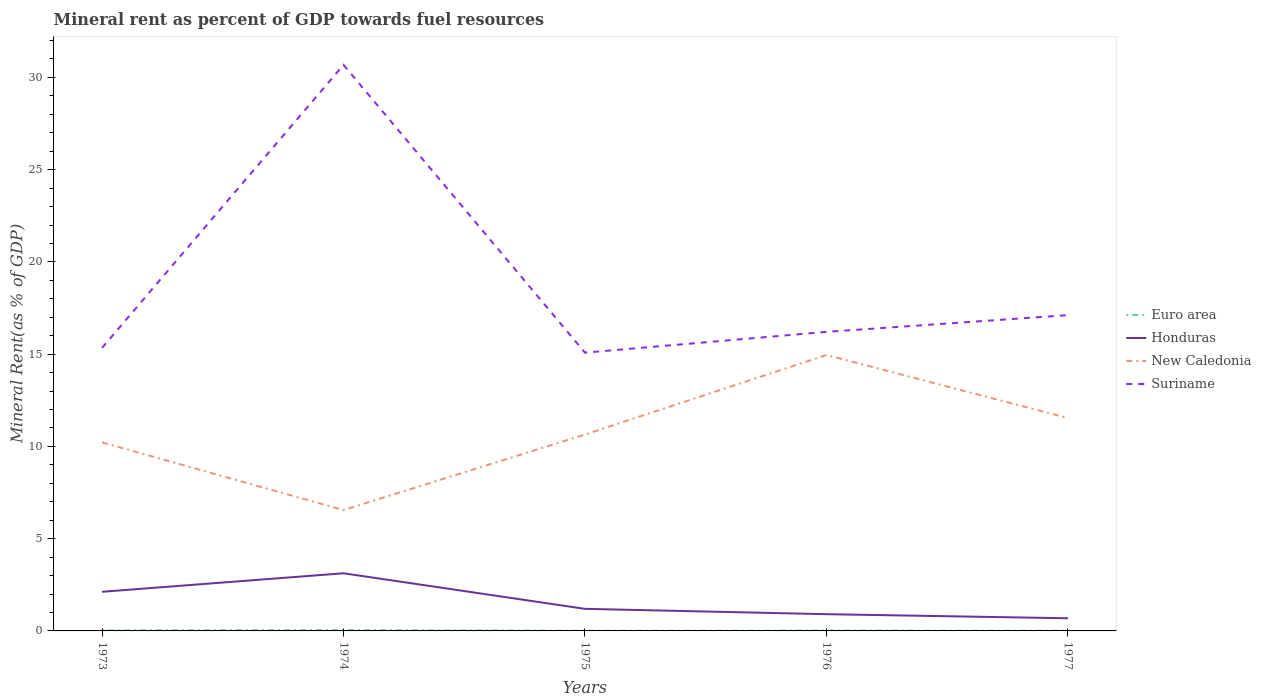Is the number of lines equal to the number of legend labels?
Ensure brevity in your answer.  Yes. Across all years, what is the maximum mineral rent in Suriname?
Ensure brevity in your answer.  15.08. In which year was the mineral rent in Honduras maximum?
Your answer should be very brief. 1977. What is the total mineral rent in Suriname in the graph?
Offer a very short reply. 15.6. What is the difference between the highest and the second highest mineral rent in Euro area?
Offer a terse response. 0.03. What is the difference between the highest and the lowest mineral rent in New Caledonia?
Make the answer very short. 2. What is the difference between two consecutive major ticks on the Y-axis?
Ensure brevity in your answer.  5. Are the values on the major ticks of Y-axis written in scientific E-notation?
Offer a very short reply. No. Where does the legend appear in the graph?
Offer a terse response. Center right. What is the title of the graph?
Provide a succinct answer. Mineral rent as percent of GDP towards fuel resources. What is the label or title of the Y-axis?
Your answer should be very brief. Mineral Rent(as % of GDP). What is the Mineral Rent(as % of GDP) of Euro area in 1973?
Your answer should be compact. 0.03. What is the Mineral Rent(as % of GDP) of Honduras in 1973?
Provide a succinct answer. 2.12. What is the Mineral Rent(as % of GDP) of New Caledonia in 1973?
Your answer should be very brief. 10.22. What is the Mineral Rent(as % of GDP) of Suriname in 1973?
Offer a terse response. 15.34. What is the Mineral Rent(as % of GDP) of Euro area in 1974?
Keep it short and to the point. 0.05. What is the Mineral Rent(as % of GDP) in Honduras in 1974?
Your response must be concise. 3.12. What is the Mineral Rent(as % of GDP) in New Caledonia in 1974?
Your answer should be very brief. 6.55. What is the Mineral Rent(as % of GDP) of Suriname in 1974?
Provide a short and direct response. 30.68. What is the Mineral Rent(as % of GDP) of Euro area in 1975?
Provide a short and direct response. 0.01. What is the Mineral Rent(as % of GDP) of Honduras in 1975?
Give a very brief answer. 1.2. What is the Mineral Rent(as % of GDP) in New Caledonia in 1975?
Offer a very short reply. 10.64. What is the Mineral Rent(as % of GDP) of Suriname in 1975?
Your answer should be compact. 15.08. What is the Mineral Rent(as % of GDP) of Euro area in 1976?
Your response must be concise. 0.02. What is the Mineral Rent(as % of GDP) of Honduras in 1976?
Give a very brief answer. 0.91. What is the Mineral Rent(as % of GDP) in New Caledonia in 1976?
Your answer should be compact. 14.96. What is the Mineral Rent(as % of GDP) of Suriname in 1976?
Ensure brevity in your answer.  16.21. What is the Mineral Rent(as % of GDP) in Euro area in 1977?
Make the answer very short. 0.02. What is the Mineral Rent(as % of GDP) of Honduras in 1977?
Offer a very short reply. 0.69. What is the Mineral Rent(as % of GDP) in New Caledonia in 1977?
Your answer should be compact. 11.54. What is the Mineral Rent(as % of GDP) in Suriname in 1977?
Provide a short and direct response. 17.12. Across all years, what is the maximum Mineral Rent(as % of GDP) in Euro area?
Make the answer very short. 0.05. Across all years, what is the maximum Mineral Rent(as % of GDP) of Honduras?
Provide a short and direct response. 3.12. Across all years, what is the maximum Mineral Rent(as % of GDP) of New Caledonia?
Your answer should be very brief. 14.96. Across all years, what is the maximum Mineral Rent(as % of GDP) of Suriname?
Your answer should be compact. 30.68. Across all years, what is the minimum Mineral Rent(as % of GDP) in Euro area?
Offer a very short reply. 0.01. Across all years, what is the minimum Mineral Rent(as % of GDP) in Honduras?
Give a very brief answer. 0.69. Across all years, what is the minimum Mineral Rent(as % of GDP) in New Caledonia?
Provide a succinct answer. 6.55. Across all years, what is the minimum Mineral Rent(as % of GDP) in Suriname?
Offer a very short reply. 15.08. What is the total Mineral Rent(as % of GDP) in Euro area in the graph?
Make the answer very short. 0.13. What is the total Mineral Rent(as % of GDP) of Honduras in the graph?
Offer a terse response. 8.04. What is the total Mineral Rent(as % of GDP) in New Caledonia in the graph?
Make the answer very short. 53.91. What is the total Mineral Rent(as % of GDP) of Suriname in the graph?
Your answer should be compact. 94.43. What is the difference between the Mineral Rent(as % of GDP) of Euro area in 1973 and that in 1974?
Provide a short and direct response. -0.01. What is the difference between the Mineral Rent(as % of GDP) of Honduras in 1973 and that in 1974?
Provide a succinct answer. -1. What is the difference between the Mineral Rent(as % of GDP) of New Caledonia in 1973 and that in 1974?
Ensure brevity in your answer.  3.67. What is the difference between the Mineral Rent(as % of GDP) in Suriname in 1973 and that in 1974?
Keep it short and to the point. -15.34. What is the difference between the Mineral Rent(as % of GDP) of Euro area in 1973 and that in 1975?
Offer a terse response. 0.02. What is the difference between the Mineral Rent(as % of GDP) of Honduras in 1973 and that in 1975?
Offer a very short reply. 0.92. What is the difference between the Mineral Rent(as % of GDP) of New Caledonia in 1973 and that in 1975?
Give a very brief answer. -0.42. What is the difference between the Mineral Rent(as % of GDP) in Suriname in 1973 and that in 1975?
Your answer should be very brief. 0.26. What is the difference between the Mineral Rent(as % of GDP) of Euro area in 1973 and that in 1976?
Make the answer very short. 0.01. What is the difference between the Mineral Rent(as % of GDP) in Honduras in 1973 and that in 1976?
Offer a very short reply. 1.21. What is the difference between the Mineral Rent(as % of GDP) of New Caledonia in 1973 and that in 1976?
Offer a very short reply. -4.74. What is the difference between the Mineral Rent(as % of GDP) of Suriname in 1973 and that in 1976?
Give a very brief answer. -0.87. What is the difference between the Mineral Rent(as % of GDP) in Euro area in 1973 and that in 1977?
Provide a short and direct response. 0.02. What is the difference between the Mineral Rent(as % of GDP) of Honduras in 1973 and that in 1977?
Offer a very short reply. 1.44. What is the difference between the Mineral Rent(as % of GDP) in New Caledonia in 1973 and that in 1977?
Provide a short and direct response. -1.32. What is the difference between the Mineral Rent(as % of GDP) in Suriname in 1973 and that in 1977?
Keep it short and to the point. -1.78. What is the difference between the Mineral Rent(as % of GDP) of Euro area in 1974 and that in 1975?
Your answer should be compact. 0.03. What is the difference between the Mineral Rent(as % of GDP) in Honduras in 1974 and that in 1975?
Offer a terse response. 1.93. What is the difference between the Mineral Rent(as % of GDP) of New Caledonia in 1974 and that in 1975?
Provide a short and direct response. -4.09. What is the difference between the Mineral Rent(as % of GDP) in Suriname in 1974 and that in 1975?
Offer a very short reply. 15.6. What is the difference between the Mineral Rent(as % of GDP) in Euro area in 1974 and that in 1976?
Your answer should be very brief. 0.03. What is the difference between the Mineral Rent(as % of GDP) in Honduras in 1974 and that in 1976?
Give a very brief answer. 2.22. What is the difference between the Mineral Rent(as % of GDP) in New Caledonia in 1974 and that in 1976?
Your answer should be very brief. -8.41. What is the difference between the Mineral Rent(as % of GDP) in Suriname in 1974 and that in 1976?
Offer a very short reply. 14.47. What is the difference between the Mineral Rent(as % of GDP) in Euro area in 1974 and that in 1977?
Keep it short and to the point. 0.03. What is the difference between the Mineral Rent(as % of GDP) of Honduras in 1974 and that in 1977?
Provide a short and direct response. 2.44. What is the difference between the Mineral Rent(as % of GDP) of New Caledonia in 1974 and that in 1977?
Give a very brief answer. -4.99. What is the difference between the Mineral Rent(as % of GDP) of Suriname in 1974 and that in 1977?
Give a very brief answer. 13.56. What is the difference between the Mineral Rent(as % of GDP) of Euro area in 1975 and that in 1976?
Keep it short and to the point. -0.01. What is the difference between the Mineral Rent(as % of GDP) of Honduras in 1975 and that in 1976?
Offer a very short reply. 0.29. What is the difference between the Mineral Rent(as % of GDP) in New Caledonia in 1975 and that in 1976?
Offer a very short reply. -4.31. What is the difference between the Mineral Rent(as % of GDP) of Suriname in 1975 and that in 1976?
Your response must be concise. -1.13. What is the difference between the Mineral Rent(as % of GDP) of Euro area in 1975 and that in 1977?
Your answer should be very brief. -0. What is the difference between the Mineral Rent(as % of GDP) in Honduras in 1975 and that in 1977?
Offer a terse response. 0.51. What is the difference between the Mineral Rent(as % of GDP) in New Caledonia in 1975 and that in 1977?
Ensure brevity in your answer.  -0.89. What is the difference between the Mineral Rent(as % of GDP) in Suriname in 1975 and that in 1977?
Ensure brevity in your answer.  -2.03. What is the difference between the Mineral Rent(as % of GDP) in Euro area in 1976 and that in 1977?
Ensure brevity in your answer.  0. What is the difference between the Mineral Rent(as % of GDP) in Honduras in 1976 and that in 1977?
Your answer should be very brief. 0.22. What is the difference between the Mineral Rent(as % of GDP) in New Caledonia in 1976 and that in 1977?
Your response must be concise. 3.42. What is the difference between the Mineral Rent(as % of GDP) in Suriname in 1976 and that in 1977?
Your response must be concise. -0.91. What is the difference between the Mineral Rent(as % of GDP) in Euro area in 1973 and the Mineral Rent(as % of GDP) in Honduras in 1974?
Give a very brief answer. -3.09. What is the difference between the Mineral Rent(as % of GDP) in Euro area in 1973 and the Mineral Rent(as % of GDP) in New Caledonia in 1974?
Offer a terse response. -6.52. What is the difference between the Mineral Rent(as % of GDP) of Euro area in 1973 and the Mineral Rent(as % of GDP) of Suriname in 1974?
Keep it short and to the point. -30.65. What is the difference between the Mineral Rent(as % of GDP) in Honduras in 1973 and the Mineral Rent(as % of GDP) in New Caledonia in 1974?
Offer a very short reply. -4.43. What is the difference between the Mineral Rent(as % of GDP) in Honduras in 1973 and the Mineral Rent(as % of GDP) in Suriname in 1974?
Provide a short and direct response. -28.56. What is the difference between the Mineral Rent(as % of GDP) in New Caledonia in 1973 and the Mineral Rent(as % of GDP) in Suriname in 1974?
Give a very brief answer. -20.46. What is the difference between the Mineral Rent(as % of GDP) of Euro area in 1973 and the Mineral Rent(as % of GDP) of Honduras in 1975?
Offer a terse response. -1.16. What is the difference between the Mineral Rent(as % of GDP) of Euro area in 1973 and the Mineral Rent(as % of GDP) of New Caledonia in 1975?
Your answer should be compact. -10.61. What is the difference between the Mineral Rent(as % of GDP) in Euro area in 1973 and the Mineral Rent(as % of GDP) in Suriname in 1975?
Provide a short and direct response. -15.05. What is the difference between the Mineral Rent(as % of GDP) of Honduras in 1973 and the Mineral Rent(as % of GDP) of New Caledonia in 1975?
Offer a very short reply. -8.52. What is the difference between the Mineral Rent(as % of GDP) of Honduras in 1973 and the Mineral Rent(as % of GDP) of Suriname in 1975?
Keep it short and to the point. -12.96. What is the difference between the Mineral Rent(as % of GDP) in New Caledonia in 1973 and the Mineral Rent(as % of GDP) in Suriname in 1975?
Your answer should be compact. -4.86. What is the difference between the Mineral Rent(as % of GDP) of Euro area in 1973 and the Mineral Rent(as % of GDP) of Honduras in 1976?
Your answer should be very brief. -0.88. What is the difference between the Mineral Rent(as % of GDP) of Euro area in 1973 and the Mineral Rent(as % of GDP) of New Caledonia in 1976?
Provide a short and direct response. -14.92. What is the difference between the Mineral Rent(as % of GDP) in Euro area in 1973 and the Mineral Rent(as % of GDP) in Suriname in 1976?
Provide a short and direct response. -16.18. What is the difference between the Mineral Rent(as % of GDP) in Honduras in 1973 and the Mineral Rent(as % of GDP) in New Caledonia in 1976?
Provide a short and direct response. -12.84. What is the difference between the Mineral Rent(as % of GDP) in Honduras in 1973 and the Mineral Rent(as % of GDP) in Suriname in 1976?
Give a very brief answer. -14.09. What is the difference between the Mineral Rent(as % of GDP) of New Caledonia in 1973 and the Mineral Rent(as % of GDP) of Suriname in 1976?
Keep it short and to the point. -5.99. What is the difference between the Mineral Rent(as % of GDP) of Euro area in 1973 and the Mineral Rent(as % of GDP) of Honduras in 1977?
Give a very brief answer. -0.65. What is the difference between the Mineral Rent(as % of GDP) of Euro area in 1973 and the Mineral Rent(as % of GDP) of New Caledonia in 1977?
Ensure brevity in your answer.  -11.51. What is the difference between the Mineral Rent(as % of GDP) in Euro area in 1973 and the Mineral Rent(as % of GDP) in Suriname in 1977?
Your response must be concise. -17.08. What is the difference between the Mineral Rent(as % of GDP) of Honduras in 1973 and the Mineral Rent(as % of GDP) of New Caledonia in 1977?
Your answer should be very brief. -9.42. What is the difference between the Mineral Rent(as % of GDP) in Honduras in 1973 and the Mineral Rent(as % of GDP) in Suriname in 1977?
Provide a succinct answer. -15. What is the difference between the Mineral Rent(as % of GDP) of New Caledonia in 1973 and the Mineral Rent(as % of GDP) of Suriname in 1977?
Ensure brevity in your answer.  -6.9. What is the difference between the Mineral Rent(as % of GDP) in Euro area in 1974 and the Mineral Rent(as % of GDP) in Honduras in 1975?
Your answer should be compact. -1.15. What is the difference between the Mineral Rent(as % of GDP) of Euro area in 1974 and the Mineral Rent(as % of GDP) of New Caledonia in 1975?
Give a very brief answer. -10.6. What is the difference between the Mineral Rent(as % of GDP) in Euro area in 1974 and the Mineral Rent(as % of GDP) in Suriname in 1975?
Your answer should be compact. -15.04. What is the difference between the Mineral Rent(as % of GDP) in Honduras in 1974 and the Mineral Rent(as % of GDP) in New Caledonia in 1975?
Your answer should be compact. -7.52. What is the difference between the Mineral Rent(as % of GDP) of Honduras in 1974 and the Mineral Rent(as % of GDP) of Suriname in 1975?
Keep it short and to the point. -11.96. What is the difference between the Mineral Rent(as % of GDP) of New Caledonia in 1974 and the Mineral Rent(as % of GDP) of Suriname in 1975?
Provide a short and direct response. -8.53. What is the difference between the Mineral Rent(as % of GDP) in Euro area in 1974 and the Mineral Rent(as % of GDP) in Honduras in 1976?
Offer a terse response. -0.86. What is the difference between the Mineral Rent(as % of GDP) in Euro area in 1974 and the Mineral Rent(as % of GDP) in New Caledonia in 1976?
Give a very brief answer. -14.91. What is the difference between the Mineral Rent(as % of GDP) of Euro area in 1974 and the Mineral Rent(as % of GDP) of Suriname in 1976?
Keep it short and to the point. -16.16. What is the difference between the Mineral Rent(as % of GDP) of Honduras in 1974 and the Mineral Rent(as % of GDP) of New Caledonia in 1976?
Offer a terse response. -11.83. What is the difference between the Mineral Rent(as % of GDP) in Honduras in 1974 and the Mineral Rent(as % of GDP) in Suriname in 1976?
Provide a short and direct response. -13.08. What is the difference between the Mineral Rent(as % of GDP) in New Caledonia in 1974 and the Mineral Rent(as % of GDP) in Suriname in 1976?
Your answer should be compact. -9.66. What is the difference between the Mineral Rent(as % of GDP) in Euro area in 1974 and the Mineral Rent(as % of GDP) in Honduras in 1977?
Your response must be concise. -0.64. What is the difference between the Mineral Rent(as % of GDP) in Euro area in 1974 and the Mineral Rent(as % of GDP) in New Caledonia in 1977?
Offer a terse response. -11.49. What is the difference between the Mineral Rent(as % of GDP) of Euro area in 1974 and the Mineral Rent(as % of GDP) of Suriname in 1977?
Your answer should be compact. -17.07. What is the difference between the Mineral Rent(as % of GDP) in Honduras in 1974 and the Mineral Rent(as % of GDP) in New Caledonia in 1977?
Offer a very short reply. -8.41. What is the difference between the Mineral Rent(as % of GDP) of Honduras in 1974 and the Mineral Rent(as % of GDP) of Suriname in 1977?
Ensure brevity in your answer.  -13.99. What is the difference between the Mineral Rent(as % of GDP) in New Caledonia in 1974 and the Mineral Rent(as % of GDP) in Suriname in 1977?
Offer a very short reply. -10.57. What is the difference between the Mineral Rent(as % of GDP) in Euro area in 1975 and the Mineral Rent(as % of GDP) in Honduras in 1976?
Make the answer very short. -0.89. What is the difference between the Mineral Rent(as % of GDP) in Euro area in 1975 and the Mineral Rent(as % of GDP) in New Caledonia in 1976?
Provide a short and direct response. -14.94. What is the difference between the Mineral Rent(as % of GDP) of Euro area in 1975 and the Mineral Rent(as % of GDP) of Suriname in 1976?
Offer a very short reply. -16.2. What is the difference between the Mineral Rent(as % of GDP) of Honduras in 1975 and the Mineral Rent(as % of GDP) of New Caledonia in 1976?
Provide a succinct answer. -13.76. What is the difference between the Mineral Rent(as % of GDP) of Honduras in 1975 and the Mineral Rent(as % of GDP) of Suriname in 1976?
Your response must be concise. -15.01. What is the difference between the Mineral Rent(as % of GDP) of New Caledonia in 1975 and the Mineral Rent(as % of GDP) of Suriname in 1976?
Your answer should be compact. -5.57. What is the difference between the Mineral Rent(as % of GDP) of Euro area in 1975 and the Mineral Rent(as % of GDP) of Honduras in 1977?
Your response must be concise. -0.67. What is the difference between the Mineral Rent(as % of GDP) of Euro area in 1975 and the Mineral Rent(as % of GDP) of New Caledonia in 1977?
Provide a short and direct response. -11.52. What is the difference between the Mineral Rent(as % of GDP) in Euro area in 1975 and the Mineral Rent(as % of GDP) in Suriname in 1977?
Give a very brief answer. -17.1. What is the difference between the Mineral Rent(as % of GDP) in Honduras in 1975 and the Mineral Rent(as % of GDP) in New Caledonia in 1977?
Ensure brevity in your answer.  -10.34. What is the difference between the Mineral Rent(as % of GDP) of Honduras in 1975 and the Mineral Rent(as % of GDP) of Suriname in 1977?
Offer a very short reply. -15.92. What is the difference between the Mineral Rent(as % of GDP) of New Caledonia in 1975 and the Mineral Rent(as % of GDP) of Suriname in 1977?
Your response must be concise. -6.47. What is the difference between the Mineral Rent(as % of GDP) of Euro area in 1976 and the Mineral Rent(as % of GDP) of Honduras in 1977?
Ensure brevity in your answer.  -0.67. What is the difference between the Mineral Rent(as % of GDP) of Euro area in 1976 and the Mineral Rent(as % of GDP) of New Caledonia in 1977?
Provide a short and direct response. -11.52. What is the difference between the Mineral Rent(as % of GDP) of Euro area in 1976 and the Mineral Rent(as % of GDP) of Suriname in 1977?
Provide a succinct answer. -17.1. What is the difference between the Mineral Rent(as % of GDP) in Honduras in 1976 and the Mineral Rent(as % of GDP) in New Caledonia in 1977?
Your response must be concise. -10.63. What is the difference between the Mineral Rent(as % of GDP) of Honduras in 1976 and the Mineral Rent(as % of GDP) of Suriname in 1977?
Your response must be concise. -16.21. What is the difference between the Mineral Rent(as % of GDP) of New Caledonia in 1976 and the Mineral Rent(as % of GDP) of Suriname in 1977?
Your response must be concise. -2.16. What is the average Mineral Rent(as % of GDP) of Euro area per year?
Provide a succinct answer. 0.03. What is the average Mineral Rent(as % of GDP) in Honduras per year?
Your answer should be compact. 1.61. What is the average Mineral Rent(as % of GDP) of New Caledonia per year?
Provide a short and direct response. 10.78. What is the average Mineral Rent(as % of GDP) in Suriname per year?
Offer a terse response. 18.89. In the year 1973, what is the difference between the Mineral Rent(as % of GDP) of Euro area and Mineral Rent(as % of GDP) of Honduras?
Provide a succinct answer. -2.09. In the year 1973, what is the difference between the Mineral Rent(as % of GDP) of Euro area and Mineral Rent(as % of GDP) of New Caledonia?
Your answer should be compact. -10.19. In the year 1973, what is the difference between the Mineral Rent(as % of GDP) of Euro area and Mineral Rent(as % of GDP) of Suriname?
Give a very brief answer. -15.31. In the year 1973, what is the difference between the Mineral Rent(as % of GDP) in Honduras and Mineral Rent(as % of GDP) in New Caledonia?
Ensure brevity in your answer.  -8.1. In the year 1973, what is the difference between the Mineral Rent(as % of GDP) in Honduras and Mineral Rent(as % of GDP) in Suriname?
Make the answer very short. -13.22. In the year 1973, what is the difference between the Mineral Rent(as % of GDP) of New Caledonia and Mineral Rent(as % of GDP) of Suriname?
Your response must be concise. -5.12. In the year 1974, what is the difference between the Mineral Rent(as % of GDP) of Euro area and Mineral Rent(as % of GDP) of Honduras?
Offer a very short reply. -3.08. In the year 1974, what is the difference between the Mineral Rent(as % of GDP) in Euro area and Mineral Rent(as % of GDP) in New Caledonia?
Your answer should be very brief. -6.51. In the year 1974, what is the difference between the Mineral Rent(as % of GDP) in Euro area and Mineral Rent(as % of GDP) in Suriname?
Provide a succinct answer. -30.64. In the year 1974, what is the difference between the Mineral Rent(as % of GDP) of Honduras and Mineral Rent(as % of GDP) of New Caledonia?
Your answer should be compact. -3.43. In the year 1974, what is the difference between the Mineral Rent(as % of GDP) in Honduras and Mineral Rent(as % of GDP) in Suriname?
Your response must be concise. -27.56. In the year 1974, what is the difference between the Mineral Rent(as % of GDP) of New Caledonia and Mineral Rent(as % of GDP) of Suriname?
Your answer should be compact. -24.13. In the year 1975, what is the difference between the Mineral Rent(as % of GDP) of Euro area and Mineral Rent(as % of GDP) of Honduras?
Provide a short and direct response. -1.18. In the year 1975, what is the difference between the Mineral Rent(as % of GDP) in Euro area and Mineral Rent(as % of GDP) in New Caledonia?
Make the answer very short. -10.63. In the year 1975, what is the difference between the Mineral Rent(as % of GDP) in Euro area and Mineral Rent(as % of GDP) in Suriname?
Offer a terse response. -15.07. In the year 1975, what is the difference between the Mineral Rent(as % of GDP) of Honduras and Mineral Rent(as % of GDP) of New Caledonia?
Offer a terse response. -9.45. In the year 1975, what is the difference between the Mineral Rent(as % of GDP) in Honduras and Mineral Rent(as % of GDP) in Suriname?
Keep it short and to the point. -13.89. In the year 1975, what is the difference between the Mineral Rent(as % of GDP) in New Caledonia and Mineral Rent(as % of GDP) in Suriname?
Your answer should be very brief. -4.44. In the year 1976, what is the difference between the Mineral Rent(as % of GDP) of Euro area and Mineral Rent(as % of GDP) of Honduras?
Offer a terse response. -0.89. In the year 1976, what is the difference between the Mineral Rent(as % of GDP) in Euro area and Mineral Rent(as % of GDP) in New Caledonia?
Your response must be concise. -14.94. In the year 1976, what is the difference between the Mineral Rent(as % of GDP) of Euro area and Mineral Rent(as % of GDP) of Suriname?
Give a very brief answer. -16.19. In the year 1976, what is the difference between the Mineral Rent(as % of GDP) in Honduras and Mineral Rent(as % of GDP) in New Caledonia?
Offer a terse response. -14.05. In the year 1976, what is the difference between the Mineral Rent(as % of GDP) of Honduras and Mineral Rent(as % of GDP) of Suriname?
Provide a short and direct response. -15.3. In the year 1976, what is the difference between the Mineral Rent(as % of GDP) in New Caledonia and Mineral Rent(as % of GDP) in Suriname?
Your answer should be very brief. -1.25. In the year 1977, what is the difference between the Mineral Rent(as % of GDP) in Euro area and Mineral Rent(as % of GDP) in Honduras?
Ensure brevity in your answer.  -0.67. In the year 1977, what is the difference between the Mineral Rent(as % of GDP) in Euro area and Mineral Rent(as % of GDP) in New Caledonia?
Offer a very short reply. -11.52. In the year 1977, what is the difference between the Mineral Rent(as % of GDP) in Euro area and Mineral Rent(as % of GDP) in Suriname?
Offer a very short reply. -17.1. In the year 1977, what is the difference between the Mineral Rent(as % of GDP) of Honduras and Mineral Rent(as % of GDP) of New Caledonia?
Ensure brevity in your answer.  -10.85. In the year 1977, what is the difference between the Mineral Rent(as % of GDP) of Honduras and Mineral Rent(as % of GDP) of Suriname?
Your response must be concise. -16.43. In the year 1977, what is the difference between the Mineral Rent(as % of GDP) in New Caledonia and Mineral Rent(as % of GDP) in Suriname?
Offer a very short reply. -5.58. What is the ratio of the Mineral Rent(as % of GDP) of Euro area in 1973 to that in 1974?
Provide a succinct answer. 0.7. What is the ratio of the Mineral Rent(as % of GDP) in Honduras in 1973 to that in 1974?
Provide a short and direct response. 0.68. What is the ratio of the Mineral Rent(as % of GDP) of New Caledonia in 1973 to that in 1974?
Offer a terse response. 1.56. What is the ratio of the Mineral Rent(as % of GDP) in Suriname in 1973 to that in 1974?
Make the answer very short. 0.5. What is the ratio of the Mineral Rent(as % of GDP) in Euro area in 1973 to that in 1975?
Provide a short and direct response. 2.56. What is the ratio of the Mineral Rent(as % of GDP) in Honduras in 1973 to that in 1975?
Your answer should be very brief. 1.77. What is the ratio of the Mineral Rent(as % of GDP) in New Caledonia in 1973 to that in 1975?
Your answer should be very brief. 0.96. What is the ratio of the Mineral Rent(as % of GDP) in Suriname in 1973 to that in 1975?
Your response must be concise. 1.02. What is the ratio of the Mineral Rent(as % of GDP) in Euro area in 1973 to that in 1976?
Provide a short and direct response. 1.63. What is the ratio of the Mineral Rent(as % of GDP) in Honduras in 1973 to that in 1976?
Offer a very short reply. 2.34. What is the ratio of the Mineral Rent(as % of GDP) of New Caledonia in 1973 to that in 1976?
Ensure brevity in your answer.  0.68. What is the ratio of the Mineral Rent(as % of GDP) of Suriname in 1973 to that in 1976?
Provide a short and direct response. 0.95. What is the ratio of the Mineral Rent(as % of GDP) of Euro area in 1973 to that in 1977?
Provide a succinct answer. 2.02. What is the ratio of the Mineral Rent(as % of GDP) of Honduras in 1973 to that in 1977?
Provide a succinct answer. 3.09. What is the ratio of the Mineral Rent(as % of GDP) of New Caledonia in 1973 to that in 1977?
Ensure brevity in your answer.  0.89. What is the ratio of the Mineral Rent(as % of GDP) in Suriname in 1973 to that in 1977?
Provide a succinct answer. 0.9. What is the ratio of the Mineral Rent(as % of GDP) in Euro area in 1974 to that in 1975?
Offer a very short reply. 3.65. What is the ratio of the Mineral Rent(as % of GDP) in Honduras in 1974 to that in 1975?
Offer a terse response. 2.61. What is the ratio of the Mineral Rent(as % of GDP) of New Caledonia in 1974 to that in 1975?
Offer a very short reply. 0.62. What is the ratio of the Mineral Rent(as % of GDP) in Suriname in 1974 to that in 1975?
Your response must be concise. 2.03. What is the ratio of the Mineral Rent(as % of GDP) of Euro area in 1974 to that in 1976?
Offer a terse response. 2.33. What is the ratio of the Mineral Rent(as % of GDP) in Honduras in 1974 to that in 1976?
Your answer should be very brief. 3.44. What is the ratio of the Mineral Rent(as % of GDP) in New Caledonia in 1974 to that in 1976?
Make the answer very short. 0.44. What is the ratio of the Mineral Rent(as % of GDP) of Suriname in 1974 to that in 1976?
Provide a short and direct response. 1.89. What is the ratio of the Mineral Rent(as % of GDP) in Euro area in 1974 to that in 1977?
Ensure brevity in your answer.  2.87. What is the ratio of the Mineral Rent(as % of GDP) in Honduras in 1974 to that in 1977?
Your answer should be compact. 4.56. What is the ratio of the Mineral Rent(as % of GDP) in New Caledonia in 1974 to that in 1977?
Provide a succinct answer. 0.57. What is the ratio of the Mineral Rent(as % of GDP) in Suriname in 1974 to that in 1977?
Provide a short and direct response. 1.79. What is the ratio of the Mineral Rent(as % of GDP) in Euro area in 1975 to that in 1976?
Keep it short and to the point. 0.64. What is the ratio of the Mineral Rent(as % of GDP) in Honduras in 1975 to that in 1976?
Keep it short and to the point. 1.32. What is the ratio of the Mineral Rent(as % of GDP) of New Caledonia in 1975 to that in 1976?
Your answer should be very brief. 0.71. What is the ratio of the Mineral Rent(as % of GDP) of Suriname in 1975 to that in 1976?
Offer a very short reply. 0.93. What is the ratio of the Mineral Rent(as % of GDP) in Euro area in 1975 to that in 1977?
Your answer should be compact. 0.79. What is the ratio of the Mineral Rent(as % of GDP) of Honduras in 1975 to that in 1977?
Your answer should be very brief. 1.74. What is the ratio of the Mineral Rent(as % of GDP) of New Caledonia in 1975 to that in 1977?
Provide a succinct answer. 0.92. What is the ratio of the Mineral Rent(as % of GDP) of Suriname in 1975 to that in 1977?
Keep it short and to the point. 0.88. What is the ratio of the Mineral Rent(as % of GDP) in Euro area in 1976 to that in 1977?
Make the answer very short. 1.23. What is the ratio of the Mineral Rent(as % of GDP) of Honduras in 1976 to that in 1977?
Keep it short and to the point. 1.32. What is the ratio of the Mineral Rent(as % of GDP) in New Caledonia in 1976 to that in 1977?
Offer a terse response. 1.3. What is the ratio of the Mineral Rent(as % of GDP) in Suriname in 1976 to that in 1977?
Give a very brief answer. 0.95. What is the difference between the highest and the second highest Mineral Rent(as % of GDP) in Euro area?
Offer a terse response. 0.01. What is the difference between the highest and the second highest Mineral Rent(as % of GDP) of Honduras?
Provide a succinct answer. 1. What is the difference between the highest and the second highest Mineral Rent(as % of GDP) in New Caledonia?
Keep it short and to the point. 3.42. What is the difference between the highest and the second highest Mineral Rent(as % of GDP) in Suriname?
Your answer should be very brief. 13.56. What is the difference between the highest and the lowest Mineral Rent(as % of GDP) of Euro area?
Keep it short and to the point. 0.03. What is the difference between the highest and the lowest Mineral Rent(as % of GDP) in Honduras?
Make the answer very short. 2.44. What is the difference between the highest and the lowest Mineral Rent(as % of GDP) in New Caledonia?
Provide a succinct answer. 8.41. What is the difference between the highest and the lowest Mineral Rent(as % of GDP) in Suriname?
Your answer should be compact. 15.6. 